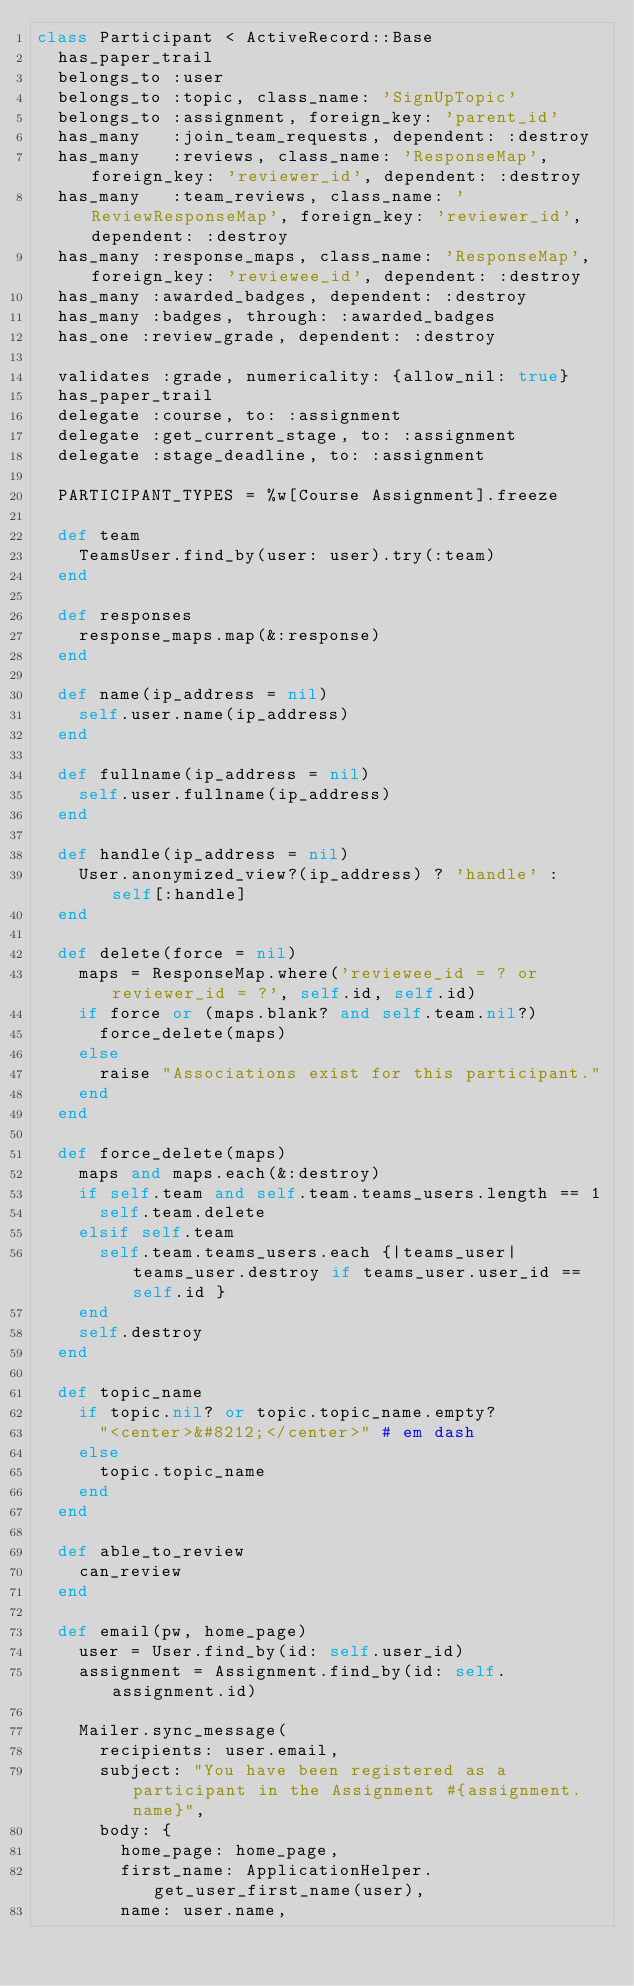<code> <loc_0><loc_0><loc_500><loc_500><_Ruby_>class Participant < ActiveRecord::Base
  has_paper_trail
  belongs_to :user
  belongs_to :topic, class_name: 'SignUpTopic'
  belongs_to :assignment, foreign_key: 'parent_id'
  has_many   :join_team_requests, dependent: :destroy
  has_many   :reviews, class_name: 'ResponseMap', foreign_key: 'reviewer_id', dependent: :destroy
  has_many   :team_reviews, class_name: 'ReviewResponseMap', foreign_key: 'reviewer_id', dependent: :destroy
  has_many :response_maps, class_name: 'ResponseMap', foreign_key: 'reviewee_id', dependent: :destroy
  has_many :awarded_badges, dependent: :destroy
  has_many :badges, through: :awarded_badges
  has_one :review_grade, dependent: :destroy

  validates :grade, numericality: {allow_nil: true}
  has_paper_trail
  delegate :course, to: :assignment
  delegate :get_current_stage, to: :assignment
  delegate :stage_deadline, to: :assignment

  PARTICIPANT_TYPES = %w[Course Assignment].freeze

  def team
    TeamsUser.find_by(user: user).try(:team)
  end

  def responses
    response_maps.map(&:response)
  end

  def name(ip_address = nil)
    self.user.name(ip_address)
  end

  def fullname(ip_address = nil)
    self.user.fullname(ip_address)
  end

  def handle(ip_address = nil)
    User.anonymized_view?(ip_address) ? 'handle' : self[:handle]
  end

  def delete(force = nil)
    maps = ResponseMap.where('reviewee_id = ? or reviewer_id = ?', self.id, self.id)
    if force or (maps.blank? and self.team.nil?)
      force_delete(maps)
    else
      raise "Associations exist for this participant."
    end
  end

  def force_delete(maps)
    maps and maps.each(&:destroy)
    if self.team and self.team.teams_users.length == 1
      self.team.delete
    elsif self.team
      self.team.teams_users.each {|teams_user| teams_user.destroy if teams_user.user_id == self.id }
    end
    self.destroy
  end

  def topic_name
    if topic.nil? or topic.topic_name.empty?
      "<center>&#8212;</center>" # em dash
    else
      topic.topic_name
    end
  end

  def able_to_review
    can_review
  end

  def email(pw, home_page)
    user = User.find_by(id: self.user_id)
    assignment = Assignment.find_by(id: self.assignment.id)

    Mailer.sync_message(
      recipients: user.email,
      subject: "You have been registered as a participant in the Assignment #{assignment.name}",
      body: {
        home_page: home_page,
        first_name: ApplicationHelper.get_user_first_name(user),
        name: user.name,</code> 